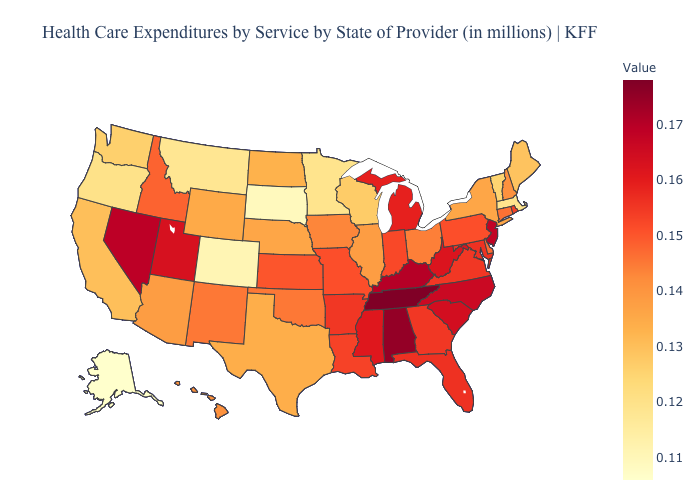Does South Dakota have the lowest value in the USA?
Answer briefly. No. Which states have the lowest value in the West?
Short answer required. Alaska. Which states hav the highest value in the MidWest?
Keep it brief. Michigan. Which states have the lowest value in the West?
Answer briefly. Alaska. Does Virginia have the lowest value in the USA?
Be succinct. No. Among the states that border West Virginia , does Ohio have the lowest value?
Quick response, please. Yes. Does the map have missing data?
Give a very brief answer. No. Among the states that border Kentucky , which have the highest value?
Short answer required. Tennessee. Does Oklahoma have a lower value than Georgia?
Concise answer only. Yes. 